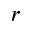Convert formula to latex. <formula><loc_0><loc_0><loc_500><loc_500>r</formula> 